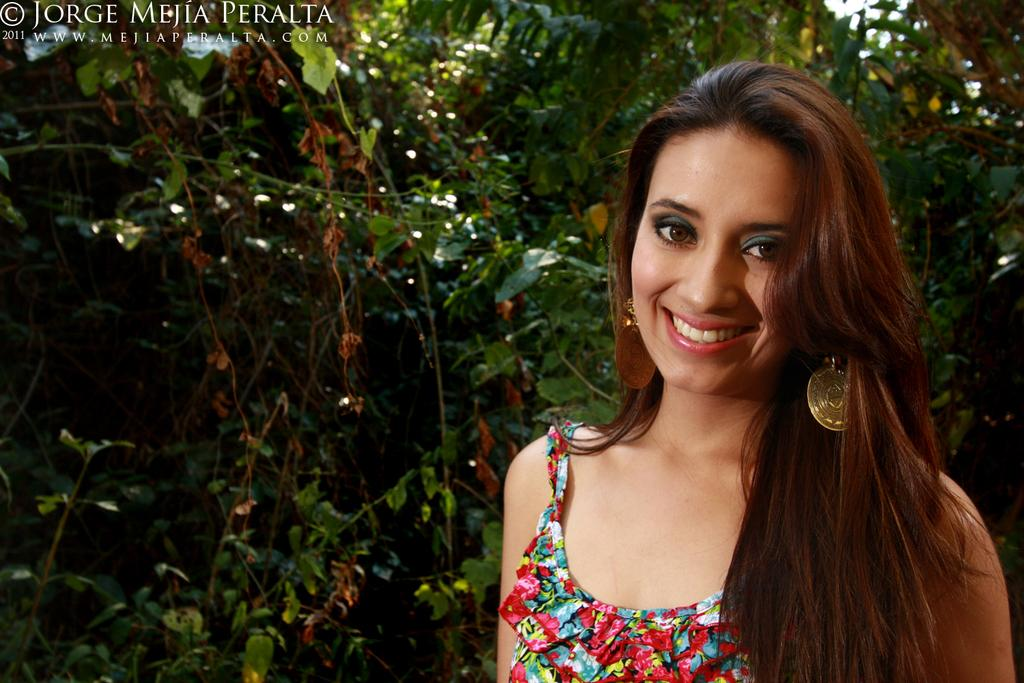Who is present in the image? There is a woman in the image. What is the woman's expression? The woman is smiling. What can be seen in the background of the image? There are trees in the background of the image. Is there any additional information about the image itself? Yes, there is a watermark on the image. What type of voyage is the woman embarking on in the image? There is no indication of a voyage in the image; it simply shows a woman smiling with trees in the background. 